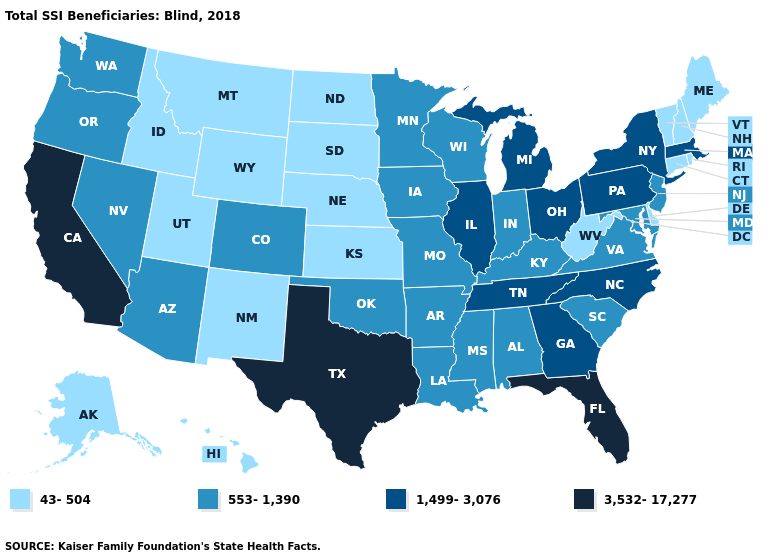Which states hav the highest value in the Northeast?
Be succinct. Massachusetts, New York, Pennsylvania. What is the value of Montana?
Give a very brief answer. 43-504. Name the states that have a value in the range 43-504?
Short answer required. Alaska, Connecticut, Delaware, Hawaii, Idaho, Kansas, Maine, Montana, Nebraska, New Hampshire, New Mexico, North Dakota, Rhode Island, South Dakota, Utah, Vermont, West Virginia, Wyoming. Does New Mexico have the lowest value in the USA?
Short answer required. Yes. What is the lowest value in the USA?
Keep it brief. 43-504. Name the states that have a value in the range 1,499-3,076?
Give a very brief answer. Georgia, Illinois, Massachusetts, Michigan, New York, North Carolina, Ohio, Pennsylvania, Tennessee. Name the states that have a value in the range 3,532-17,277?
Quick response, please. California, Florida, Texas. Name the states that have a value in the range 553-1,390?
Be succinct. Alabama, Arizona, Arkansas, Colorado, Indiana, Iowa, Kentucky, Louisiana, Maryland, Minnesota, Mississippi, Missouri, Nevada, New Jersey, Oklahoma, Oregon, South Carolina, Virginia, Washington, Wisconsin. Which states have the lowest value in the USA?
Answer briefly. Alaska, Connecticut, Delaware, Hawaii, Idaho, Kansas, Maine, Montana, Nebraska, New Hampshire, New Mexico, North Dakota, Rhode Island, South Dakota, Utah, Vermont, West Virginia, Wyoming. What is the lowest value in the South?
Be succinct. 43-504. Does Georgia have the same value as New York?
Give a very brief answer. Yes. Which states hav the highest value in the South?
Be succinct. Florida, Texas. Name the states that have a value in the range 43-504?
Write a very short answer. Alaska, Connecticut, Delaware, Hawaii, Idaho, Kansas, Maine, Montana, Nebraska, New Hampshire, New Mexico, North Dakota, Rhode Island, South Dakota, Utah, Vermont, West Virginia, Wyoming. Does Wisconsin have a higher value than Massachusetts?
Keep it brief. No. What is the lowest value in the MidWest?
Answer briefly. 43-504. 